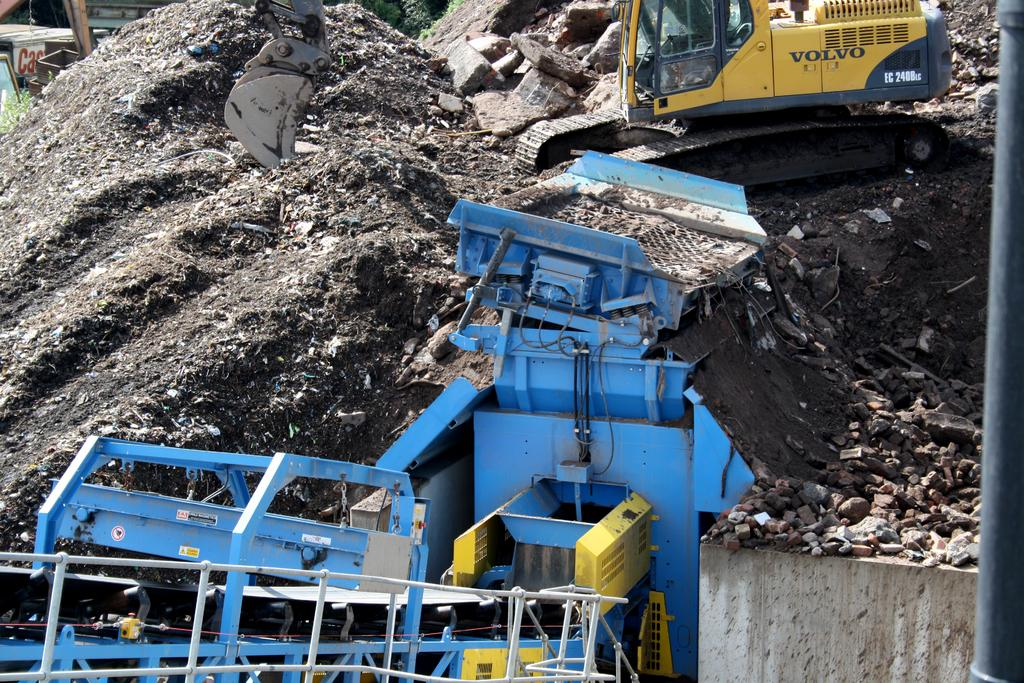How many vehicles can be seen in the image? There are two vehicles in the image. Where are the vehicles located? The vehicles are in a dump yard. What else is visible in the image besides the vehicles? There is a wall visible in the image. Can you describe any other objects in the image? There is a black color pipe in the image. How does the roof of the vehicles make a decision in the image? There are no roofs making decisions in the image, as vehicles do not have the ability to make decisions. 